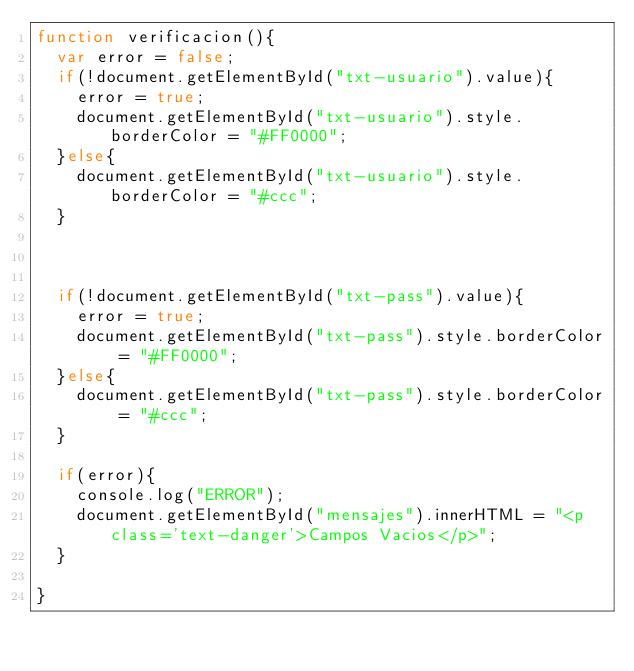Convert code to text. <code><loc_0><loc_0><loc_500><loc_500><_JavaScript_>function verificacion(){
	var error = false;
	if(!document.getElementById("txt-usuario").value){
		error = true;
		document.getElementById("txt-usuario").style.borderColor = "#FF0000";
	}else{
		document.getElementById("txt-usuario").style.borderColor = "#ccc";
	}



	if(!document.getElementById("txt-pass").value){
		error = true;
		document.getElementById("txt-pass").style.borderColor = "#FF0000";
	}else{
		document.getElementById("txt-pass").style.borderColor = "#ccc";
	}

	if(error){
		console.log("ERROR");
		document.getElementById("mensajes").innerHTML = "<p class='text-danger'>Campos Vacios</p>";
	}

}</code> 